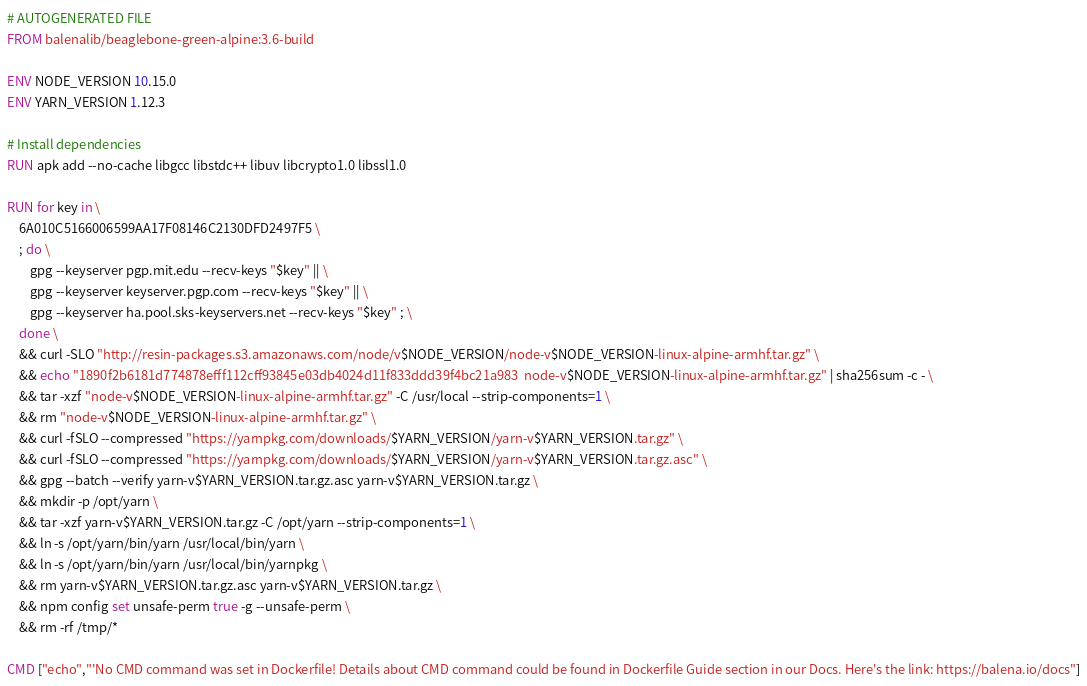<code> <loc_0><loc_0><loc_500><loc_500><_Dockerfile_># AUTOGENERATED FILE
FROM balenalib/beaglebone-green-alpine:3.6-build

ENV NODE_VERSION 10.15.0
ENV YARN_VERSION 1.12.3

# Install dependencies
RUN apk add --no-cache libgcc libstdc++ libuv libcrypto1.0 libssl1.0

RUN for key in \
	6A010C5166006599AA17F08146C2130DFD2497F5 \
	; do \
		gpg --keyserver pgp.mit.edu --recv-keys "$key" || \
		gpg --keyserver keyserver.pgp.com --recv-keys "$key" || \
		gpg --keyserver ha.pool.sks-keyservers.net --recv-keys "$key" ; \
	done \
	&& curl -SLO "http://resin-packages.s3.amazonaws.com/node/v$NODE_VERSION/node-v$NODE_VERSION-linux-alpine-armhf.tar.gz" \
	&& echo "1890f2b6181d774878efff112cff93845e03db4024d11f833ddd39f4bc21a983  node-v$NODE_VERSION-linux-alpine-armhf.tar.gz" | sha256sum -c - \
	&& tar -xzf "node-v$NODE_VERSION-linux-alpine-armhf.tar.gz" -C /usr/local --strip-components=1 \
	&& rm "node-v$NODE_VERSION-linux-alpine-armhf.tar.gz" \
	&& curl -fSLO --compressed "https://yarnpkg.com/downloads/$YARN_VERSION/yarn-v$YARN_VERSION.tar.gz" \
	&& curl -fSLO --compressed "https://yarnpkg.com/downloads/$YARN_VERSION/yarn-v$YARN_VERSION.tar.gz.asc" \
	&& gpg --batch --verify yarn-v$YARN_VERSION.tar.gz.asc yarn-v$YARN_VERSION.tar.gz \
	&& mkdir -p /opt/yarn \
	&& tar -xzf yarn-v$YARN_VERSION.tar.gz -C /opt/yarn --strip-components=1 \
	&& ln -s /opt/yarn/bin/yarn /usr/local/bin/yarn \
	&& ln -s /opt/yarn/bin/yarn /usr/local/bin/yarnpkg \
	&& rm yarn-v$YARN_VERSION.tar.gz.asc yarn-v$YARN_VERSION.tar.gz \
	&& npm config set unsafe-perm true -g --unsafe-perm \
	&& rm -rf /tmp/*

CMD ["echo","'No CMD command was set in Dockerfile! Details about CMD command could be found in Dockerfile Guide section in our Docs. Here's the link: https://balena.io/docs"]</code> 